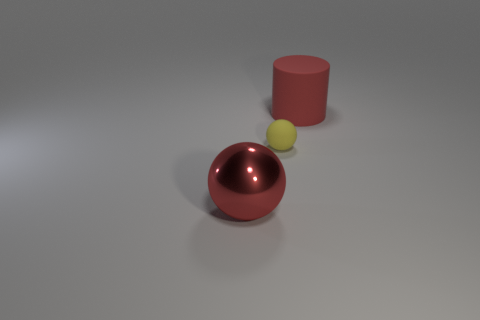Add 1 big red spheres. How many objects exist? 4 Add 3 big red objects. How many big red objects are left? 5 Add 3 red cylinders. How many red cylinders exist? 4 Subtract 1 red balls. How many objects are left? 2 Subtract all cylinders. How many objects are left? 2 Subtract all blue balls. Subtract all brown cubes. How many balls are left? 2 Subtract all red cubes. How many red spheres are left? 1 Subtract all tiny things. Subtract all yellow balls. How many objects are left? 1 